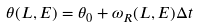<formula> <loc_0><loc_0><loc_500><loc_500>\theta ( L , E ) = \theta _ { 0 } + \omega _ { R } ( L , E ) \Delta t</formula> 